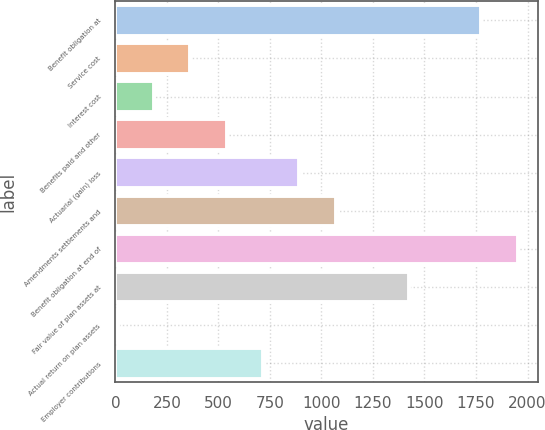Convert chart. <chart><loc_0><loc_0><loc_500><loc_500><bar_chart><fcel>Benefit obligation at<fcel>Service cost<fcel>Interest cost<fcel>Benefits paid and other<fcel>Actuarial (gain) loss<fcel>Amendments settlements and<fcel>Benefit obligation at end of<fcel>Fair value of plan assets at<fcel>Actual return on plan assets<fcel>Employer contributions<nl><fcel>1776.2<fcel>363.72<fcel>187.16<fcel>540.28<fcel>893.4<fcel>1069.96<fcel>1952.76<fcel>1423.08<fcel>10.6<fcel>716.84<nl></chart> 